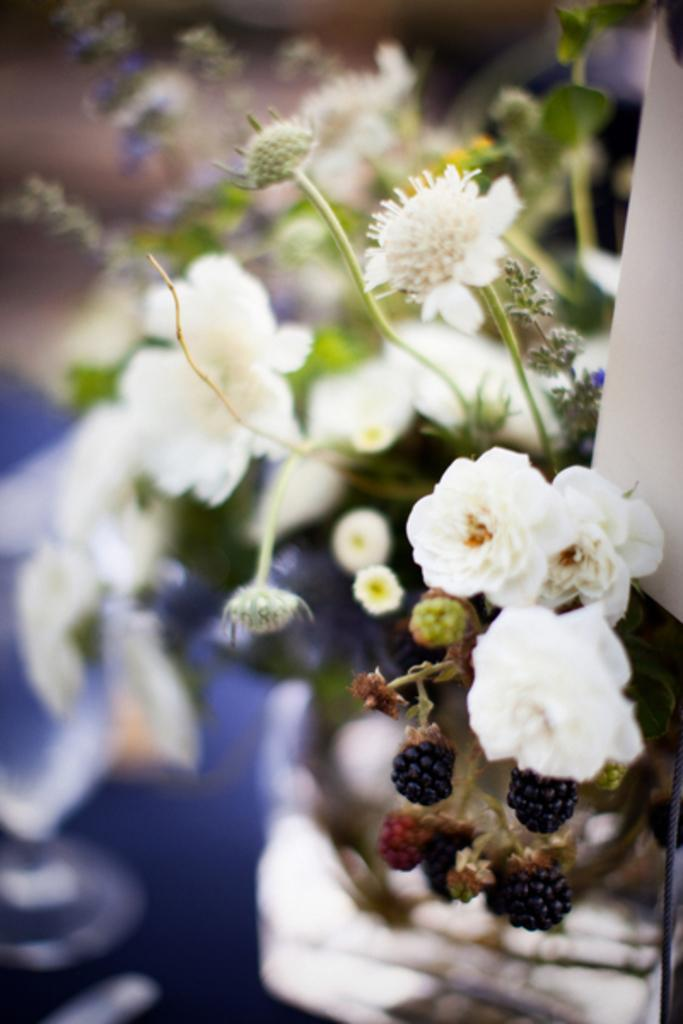What type of plant life can be seen in the image? There are flowers, berries, leaves, and buds visible in the image. What color are the flowers in the image? The flowers in the image are white in color. What part of the plant is represented by the berries in the image? The berries in the image are a part of the plant's fruit. What stage of growth are the buds in the image? The buds in the image are in the early stage of growth before blooming. How many balls are visible in the image? There are no balls present in the image; it features flowers, berries, leaves, and buds. 